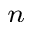Convert formula to latex. <formula><loc_0><loc_0><loc_500><loc_500>_ { n }</formula> 